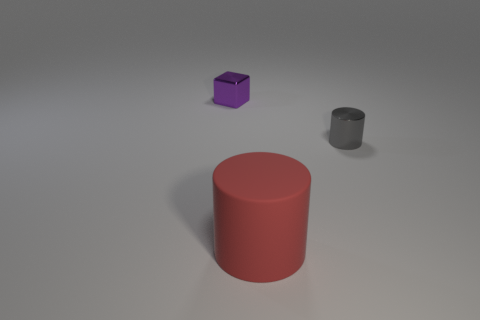Add 3 yellow rubber cylinders. How many objects exist? 6 Subtract 2 cylinders. How many cylinders are left? 0 Subtract all red cylinders. How many cylinders are left? 1 Subtract all cubes. How many objects are left? 2 Subtract 0 yellow spheres. How many objects are left? 3 Subtract all gray cubes. Subtract all cyan spheres. How many cubes are left? 1 Subtract all green metal spheres. Subtract all small objects. How many objects are left? 1 Add 2 tiny blocks. How many tiny blocks are left? 3 Add 2 tiny objects. How many tiny objects exist? 4 